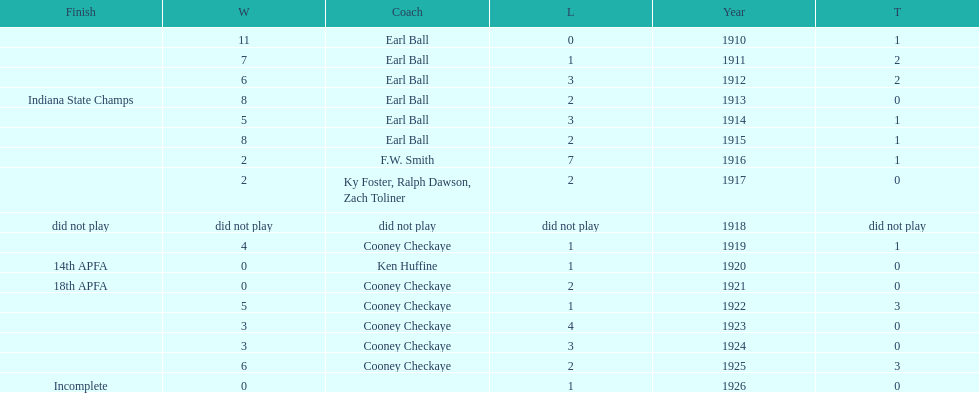How many years did cooney checkaye coach the muncie flyers? 6. 